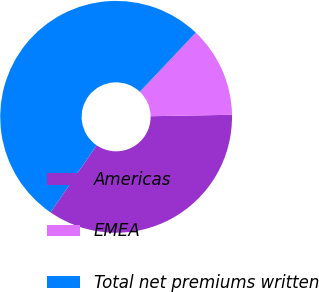<chart> <loc_0><loc_0><loc_500><loc_500><pie_chart><fcel>Americas<fcel>EMEA<fcel>Total net premiums written<nl><fcel>34.86%<fcel>12.66%<fcel>52.49%<nl></chart> 